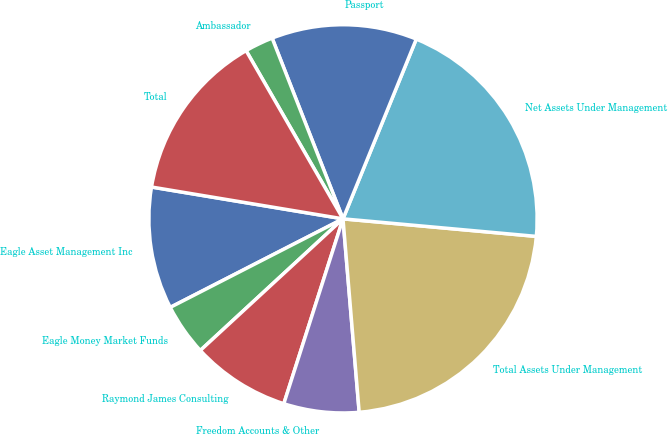Convert chart. <chart><loc_0><loc_0><loc_500><loc_500><pie_chart><fcel>Eagle Asset Management Inc<fcel>Eagle Money Market Funds<fcel>Raymond James Consulting<fcel>Freedom Accounts & Other<fcel>Total Assets Under Management<fcel>Net Assets Under Management<fcel>Passport<fcel>Ambassador<fcel>Total<nl><fcel>10.16%<fcel>4.32%<fcel>8.21%<fcel>6.26%<fcel>22.23%<fcel>20.28%<fcel>12.11%<fcel>2.37%<fcel>14.06%<nl></chart> 